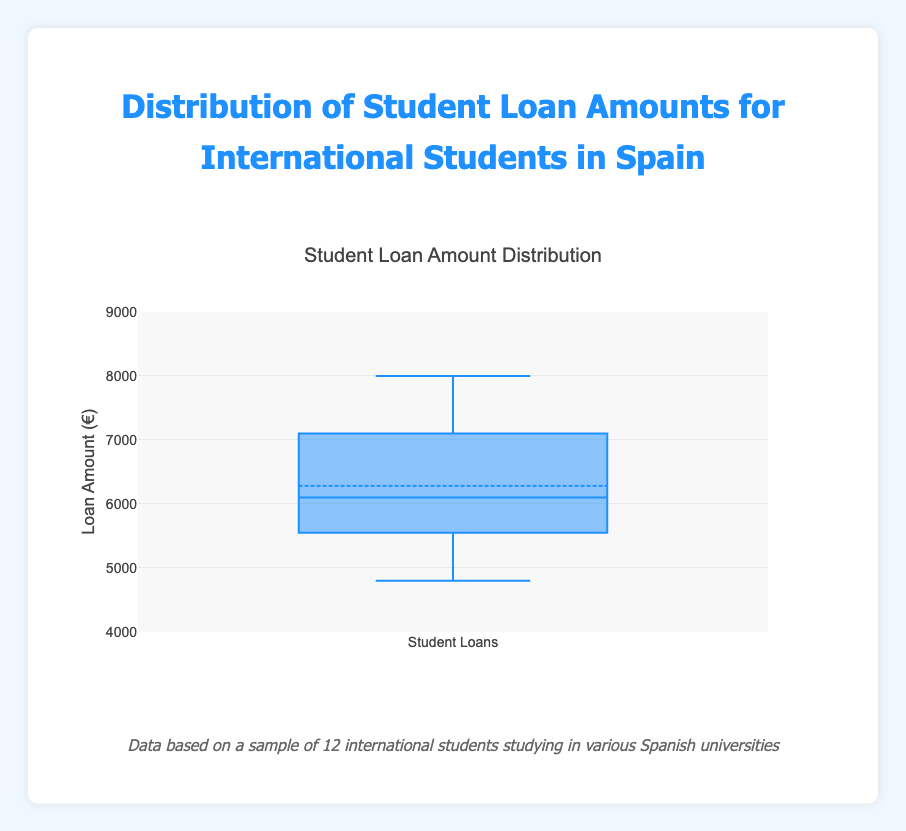What is the title of the box plot? The title of a plot is usually displayed prominently at the top of the figure. By looking at the top of this figure, we can see the text displayed.
Answer: Distribution of Student Loan Amounts for International Students in Spain What does the y-axis represent? The y-axis label indicates what is being measured on this axis. Here it reads 'Loan Amount (€)'.
Answer: Loan Amount (€) What are the approximate minimum and maximum loan amounts recorded in this plot? The box plot shows the range of data. The minimum is represented by the lowest whisker and the maximum by the highest whisker.
Answer: 4800€ and 8000€ What is the median loan amount? The box plot's median is represented by the horizontal line inside the box. We can visually inspect this line to find the median value.
Answer: 6000€ How many data points are there in this plot? In a box plot, each dot outside the whiskers or individual data points are represented within the figure. There are 12 loan amounts specified in the data.
Answer: 12 Which loan amount is the highest, and how does it compare to the median value? The highest loan amount is found at the top whisker, which is 8000€. Compare this with the median value identified as 6000€.
Answer: 8000€, which is 2000€ higher than the median What is the interquartile range (IQR) of the loan amounts? The IQR is the range between the first quartile (Q1) and the third quartile (Q3). This can be estimated from the box's lower and upper edges.
Answer: Approximately from 5600€ to 7200€, so the IQR is about 1600€ Which university likely has an outlier student loan amount and what is it? Outliers are indicated by points outside the whiskers. In this box plot, no points are outside the whiskers, hence no evident outlier.
Answer: None What is the average of the first and third quartile values? First, identify the first quartile (Q1) and third quartile (Q3) values from the box plot, then calculate their average. Q1 is approximately 5600€, and Q3 is approximately 7200€, so (5600 + 7200) / 2.
Answer: 6400€ Does the box plot indicate any skewness in the distribution of student loan amounts? Skewness can be identified by the symmetry or asymmetry of the box plot. The plot appears to be fairly symmetrical, since the median is approximately in the middle and whiskers are of similar length on both sides.
Answer: The distribution is fairly symmetrical 